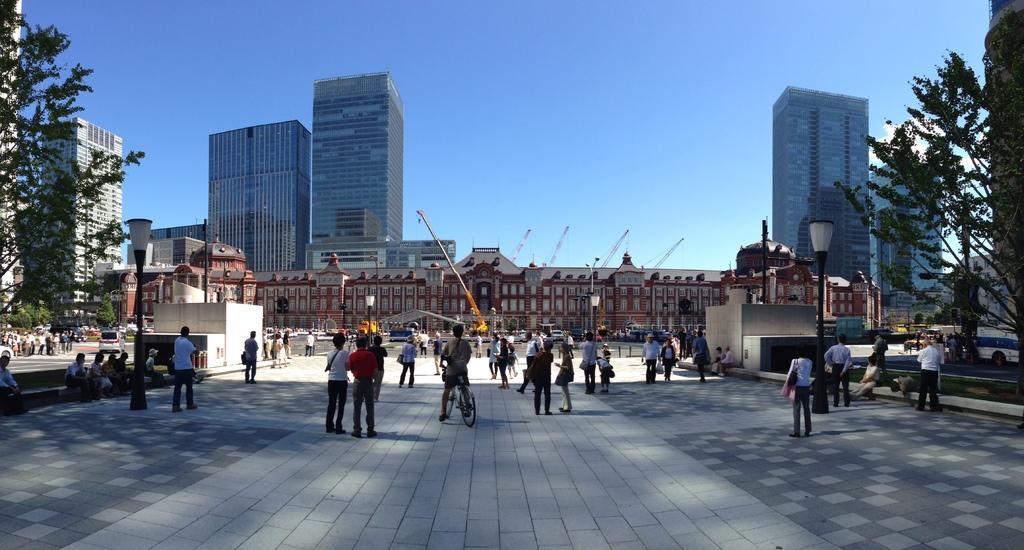How would you summarize this image in a sentence or two? In this picture we can see few people standing on the path and some are walking on the path. There is a person riding on a bicycle. There are few people sitting on stairs on the right side. We can see few trees, buildings, streetlights, cranes and other things in the background. We can see some vehicles on the path. 